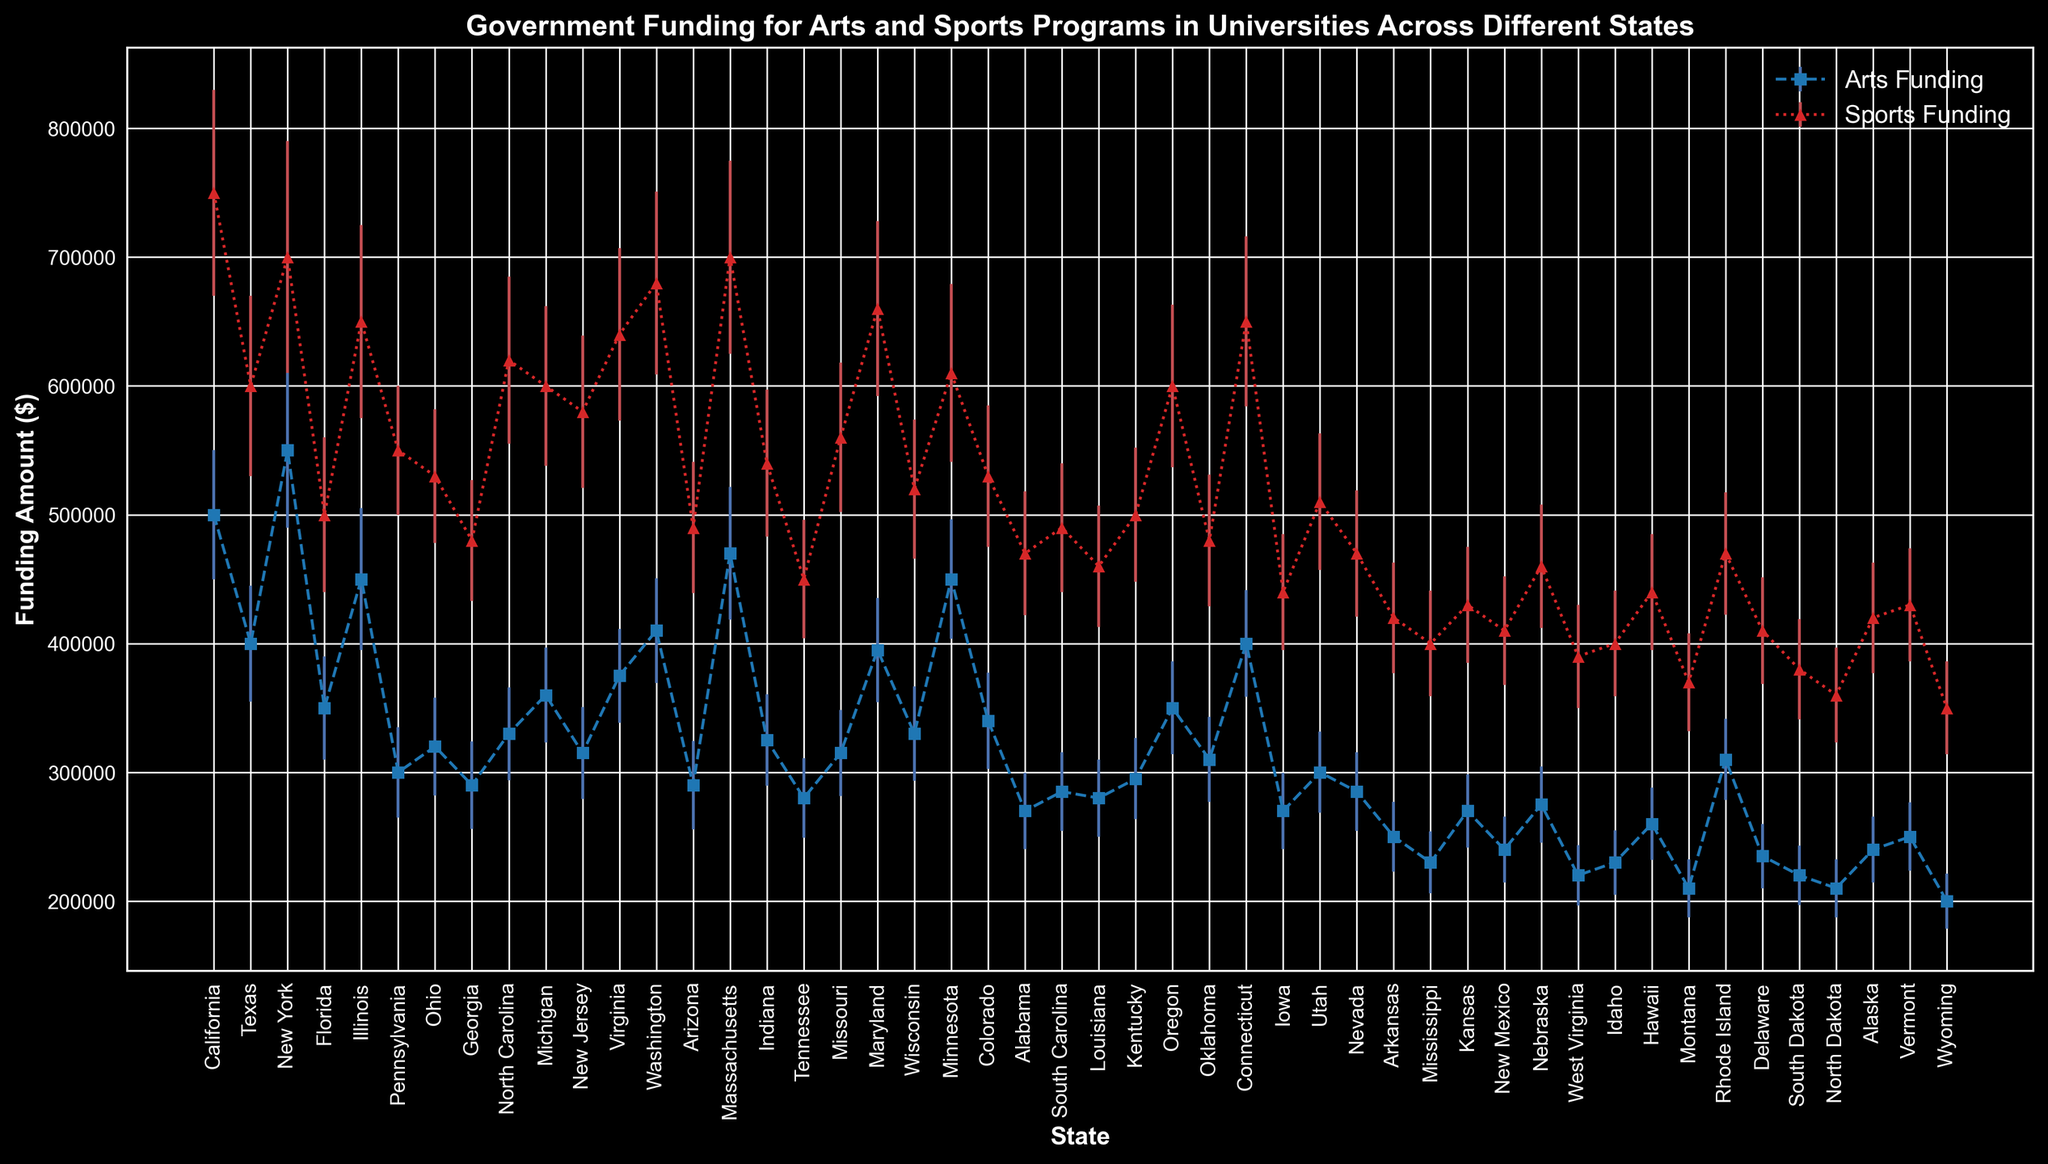Which state has the highest mean funding for Arts programs? The plotted figure shows the average funding amounts for each state. The highest mean funding for Arts programs is visually identified by the tallest marker in the blue dashed line.
Answer: New York Compare the mean funding for Arts programs between California and Texas. Which one is higher and by how much? From the figure, find the markers corresponding to California and Texas in the blue dashed line. The funding for California is 500,000 and for Texas is 400,000. The difference is 500,000 - 400,000.
Answer: California, by 100,000 Which state has the smallest standard deviation in Sports funding? Look for the state with the smallest error bars in the red dotted line, which represent the standard deviations. The smallest error bars indicate the smallest standard deviation.
Answer: Iowa How many states have a higher mean funding for Sports programs compared to Arts programs? By comparing the red dotted line (Sports funding) to the blue dashed line (Arts funding) for each state, count the states where the red marker is higher than the blue marker.
Answer: 50 states What is the cumulative funding for Arts and Sports in Illinois? Add the mean funding for Arts programs and Sports programs in Illinois together. The values are 450,000 (Arts) and 650,000 (Sports).
Answer: 1,100,000 Which states have similar mean funding for Arts and Sports programs, with differences within 50,000? Check each state where the markers for Arts and Sports funding (blue and red lines) have differences within the range of 50,000. Compare their values visually on the plot.
Answer: Nevada, Rhode Island, New Mexico What is the mean funding for Arts programs in the top three funded states? Identify the top three states with the highest markers in the blue dashed line (Arts funding), which are New York, Massachusetts, and California. Sum their values and divide by three: (550,000 + 470,000 + 500,000)/3.
Answer: 506,666.67 Which state has the highest disparity between Arts and Sports funding? Find the state with the largest vertical gap between blue dashed line markers (Arts funding) and red dotted line markers (Sports funding). Identify which state has this largest gap visually.
Answer: California 